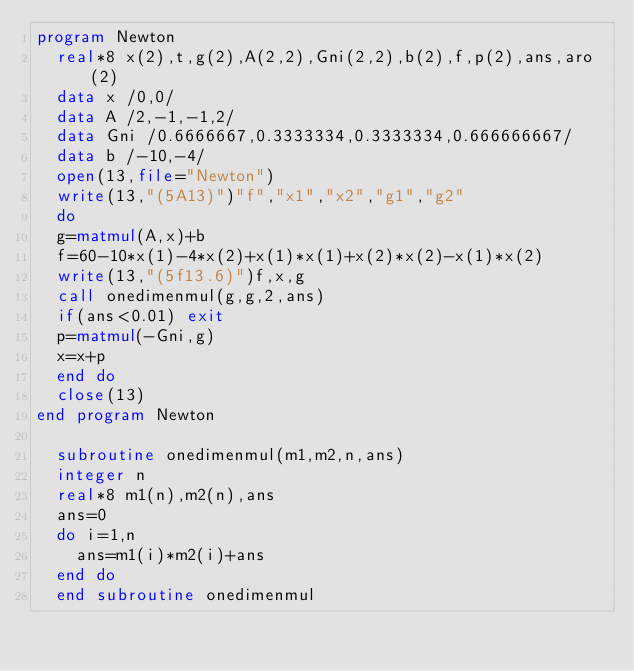<code> <loc_0><loc_0><loc_500><loc_500><_FORTRAN_>program Newton
	real*8 x(2),t,g(2),A(2,2),Gni(2,2),b(2),f,p(2),ans,aro(2)
	data x /0,0/
	data A /2,-1,-1,2/
	data Gni /0.6666667,0.3333334,0.3333334,0.666666667/
	data b /-10,-4/
	open(13,file="Newton")
	write(13,"(5A13)")"f","x1","x2","g1","g2"
	do
	g=matmul(A,x)+b
	f=60-10*x(1)-4*x(2)+x(1)*x(1)+x(2)*x(2)-x(1)*x(2)
	write(13,"(5f13.6)")f,x,g
	call onedimenmul(g,g,2,ans)
	if(ans<0.01) exit
	p=matmul(-Gni,g)
	x=x+p
	end do
	close(13)
end program Newton

	subroutine onedimenmul(m1,m2,n,ans)
	integer n
	real*8 m1(n),m2(n),ans
	ans=0
	do i=1,n
		ans=m1(i)*m2(i)+ans
	end do
	end subroutine onedimenmul
</code> 